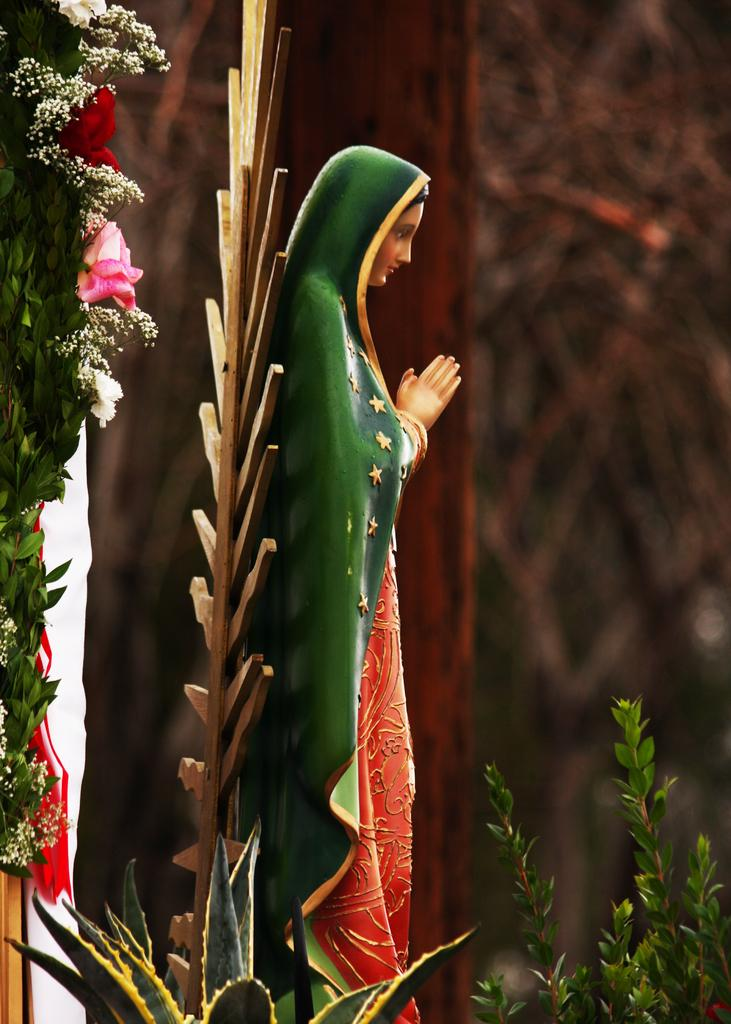What is the main subject of the image? There is a statue of a woman in the image. What colors can be seen on the statue? The statue has green and red colors. Are there any additional decorations on the statue? Yes, there are flowers decorating the statue's back. What type of fifth apparatus is being used by the statue's eye in the image? There is no fifth apparatus or any mention of the statue's eye in the image. 